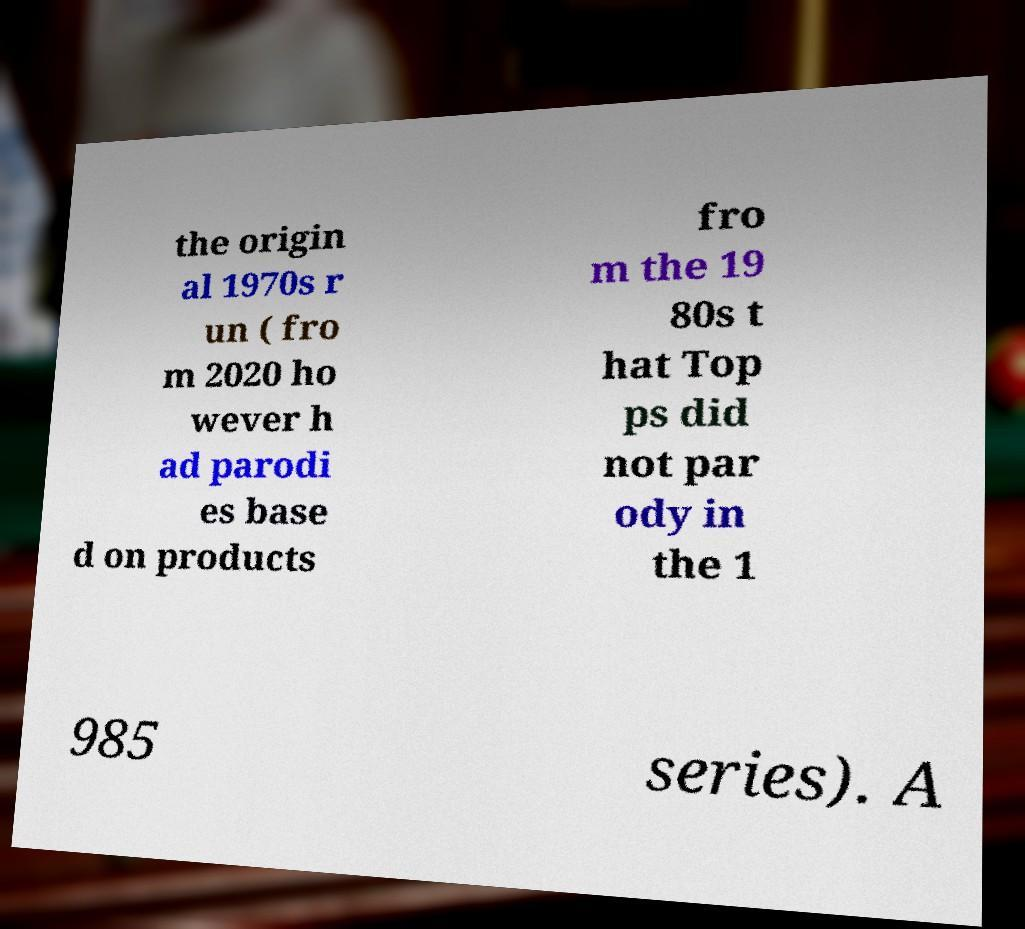For documentation purposes, I need the text within this image transcribed. Could you provide that? the origin al 1970s r un ( fro m 2020 ho wever h ad parodi es base d on products fro m the 19 80s t hat Top ps did not par ody in the 1 985 series). A 